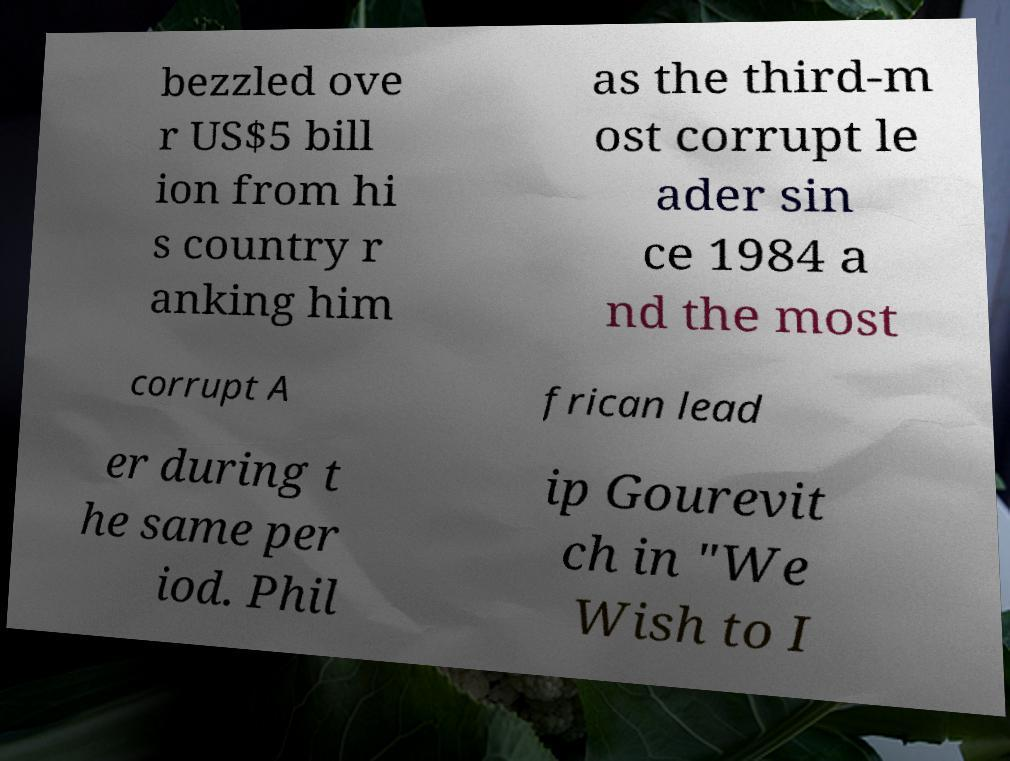For documentation purposes, I need the text within this image transcribed. Could you provide that? bezzled ove r US$5 bill ion from hi s country r anking him as the third-m ost corrupt le ader sin ce 1984 a nd the most corrupt A frican lead er during t he same per iod. Phil ip Gourevit ch in "We Wish to I 